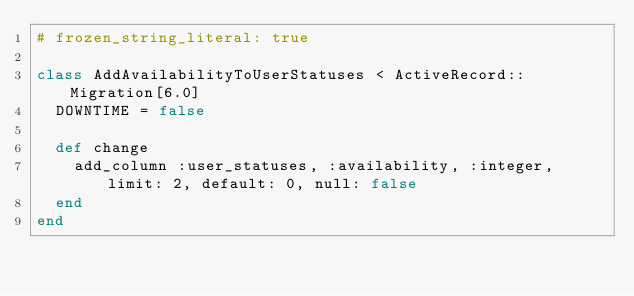Convert code to text. <code><loc_0><loc_0><loc_500><loc_500><_Ruby_># frozen_string_literal: true

class AddAvailabilityToUserStatuses < ActiveRecord::Migration[6.0]
  DOWNTIME = false

  def change
    add_column :user_statuses, :availability, :integer, limit: 2, default: 0, null: false
  end
end
</code> 